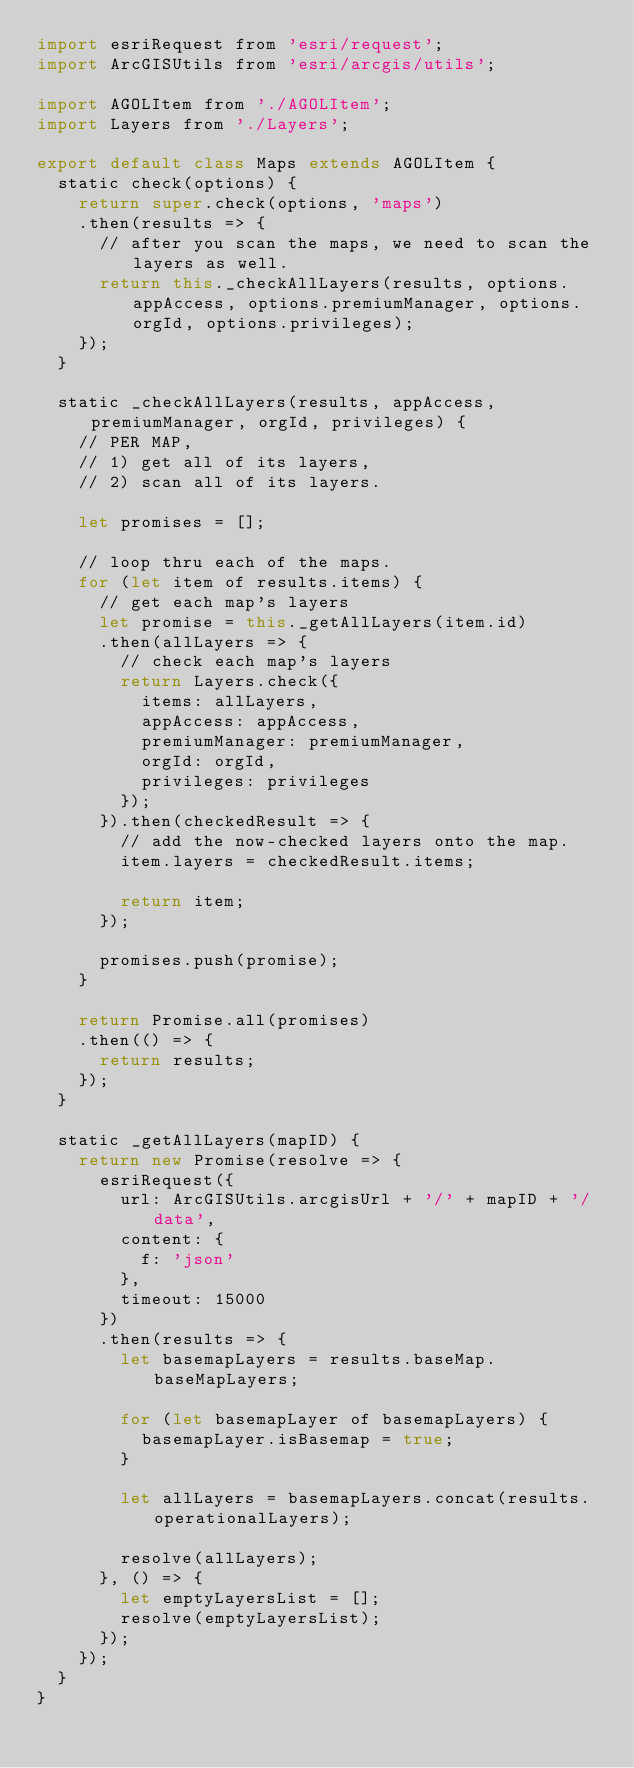<code> <loc_0><loc_0><loc_500><loc_500><_JavaScript_>import esriRequest from 'esri/request';
import ArcGISUtils from 'esri/arcgis/utils';

import AGOLItem from './AGOLItem';
import Layers from './Layers';

export default class Maps extends AGOLItem {
  static check(options) {
    return super.check(options, 'maps')
    .then(results => {
      // after you scan the maps, we need to scan the layers as well.
      return this._checkAllLayers(results, options.appAccess, options.premiumManager, options.orgId, options.privileges);
    });
  }

  static _checkAllLayers(results, appAccess, premiumManager, orgId, privileges) {
    // PER MAP,
    // 1) get all of its layers,
    // 2) scan all of its layers.

    let promises = [];

    // loop thru each of the maps.
    for (let item of results.items) {
      // get each map's layers
      let promise = this._getAllLayers(item.id)
      .then(allLayers => {
        // check each map's layers
        return Layers.check({
          items: allLayers,
          appAccess: appAccess,
          premiumManager: premiumManager,
          orgId: orgId,
          privileges: privileges
        });
      }).then(checkedResult => {
        // add the now-checked layers onto the map.
        item.layers = checkedResult.items;

        return item;
      });

      promises.push(promise);
    }

    return Promise.all(promises)
    .then(() => {
      return results;
    });
  }

  static _getAllLayers(mapID) {
    return new Promise(resolve => {
      esriRequest({
        url: ArcGISUtils.arcgisUrl + '/' + mapID + '/data',
        content: {
          f: 'json'
        },
        timeout: 15000
      })
      .then(results => {
        let basemapLayers = results.baseMap.baseMapLayers;

        for (let basemapLayer of basemapLayers) {
          basemapLayer.isBasemap = true;
        }

        let allLayers = basemapLayers.concat(results.operationalLayers);

        resolve(allLayers);
      }, () => {
        let emptyLayersList = [];
        resolve(emptyLayersList);
      });
    });
  }
}
</code> 